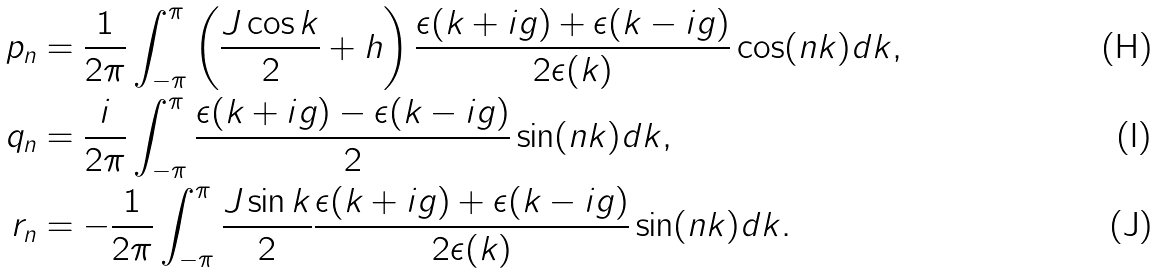Convert formula to latex. <formula><loc_0><loc_0><loc_500><loc_500>p _ { n } & = \frac { 1 } { 2 \pi } \int _ { - \pi } ^ { \pi } \left ( \frac { J \cos k } { 2 } + h \right ) \frac { \epsilon ( k + i g ) + \epsilon ( k - i g ) } { 2 \epsilon ( k ) } \cos ( n k ) d k , \\ q _ { n } & = \frac { i } { 2 \pi } \int _ { - \pi } ^ { \pi } \frac { \epsilon ( k + i g ) - \epsilon ( k - i g ) } { 2 } \sin ( n k ) d k , \\ r _ { n } & = - \frac { 1 } { 2 \pi } \int _ { - \pi } ^ { \pi } \frac { J \sin k } { 2 } \frac { \epsilon ( k + i g ) + \epsilon ( k - i g ) } { 2 \epsilon ( k ) } \sin ( n k ) d k .</formula> 